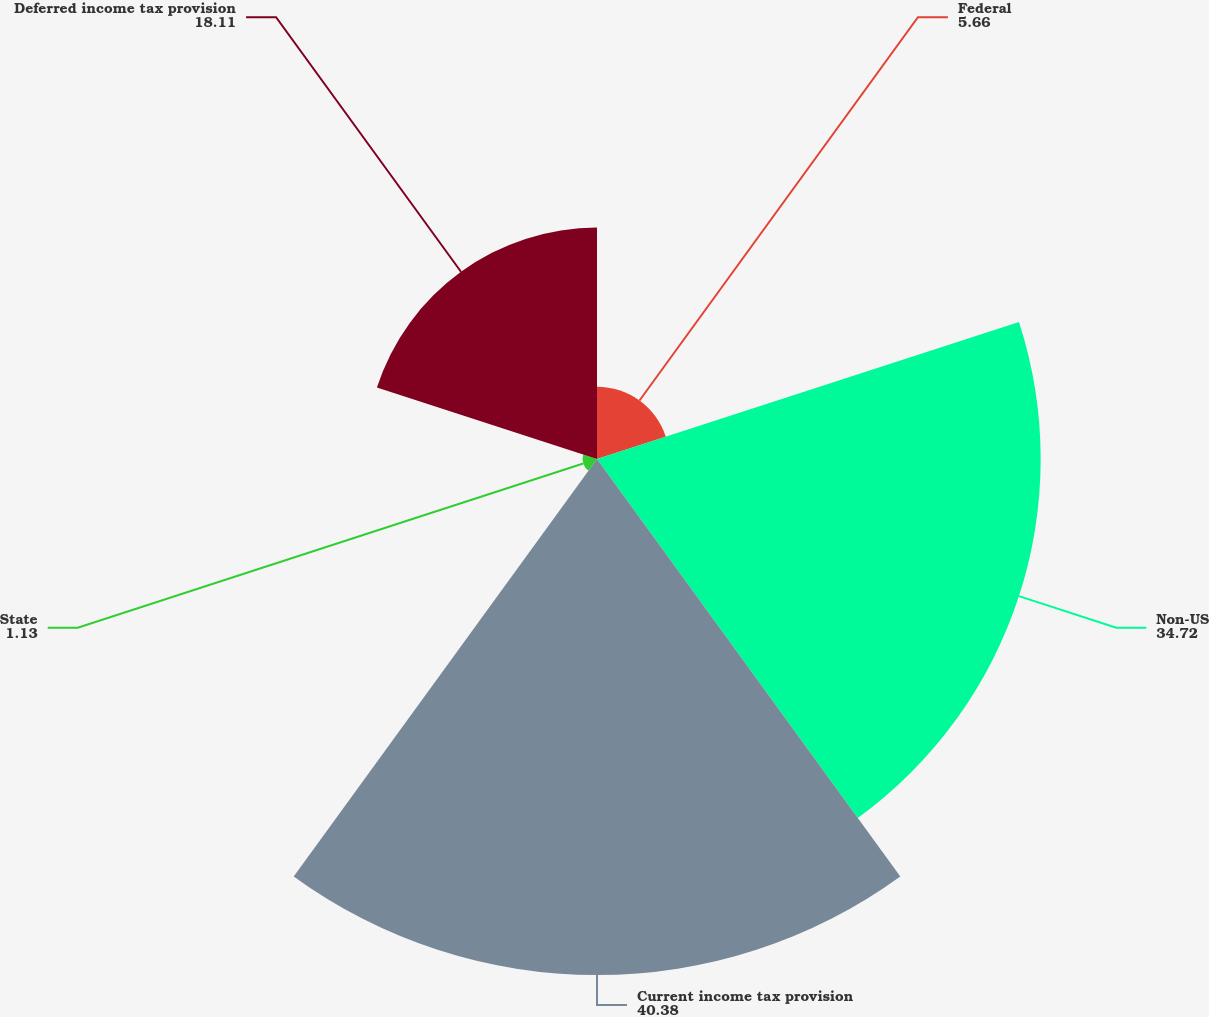<chart> <loc_0><loc_0><loc_500><loc_500><pie_chart><fcel>Federal<fcel>Non-US<fcel>Current income tax provision<fcel>State<fcel>Deferred income tax provision<nl><fcel>5.66%<fcel>34.72%<fcel>40.38%<fcel>1.13%<fcel>18.11%<nl></chart> 